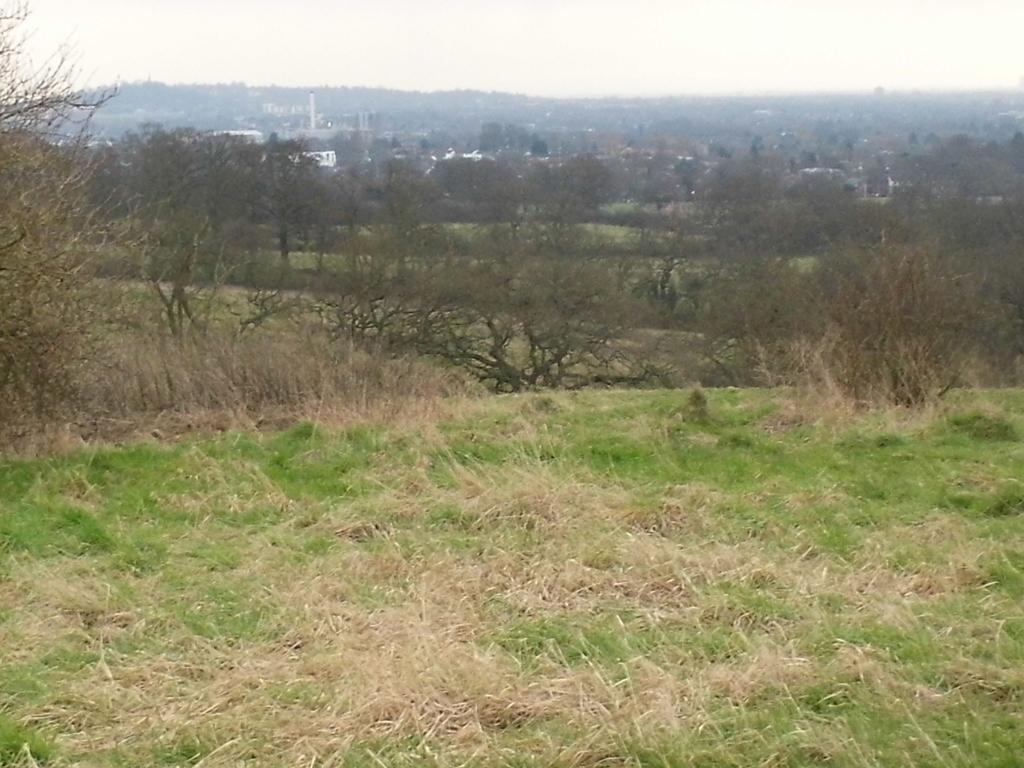Can you describe this image briefly? In the center of the image there are trees. At the bottom there is grass. In the background we can see buildings, hill and sky. 